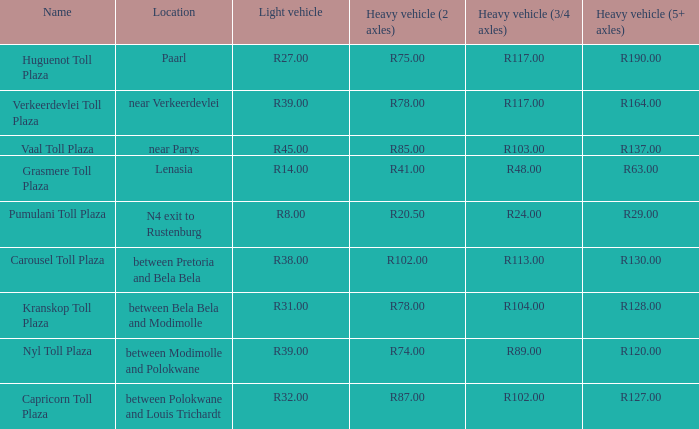What is the place of the carousel toll plaza? Between pretoria and bela bela. 